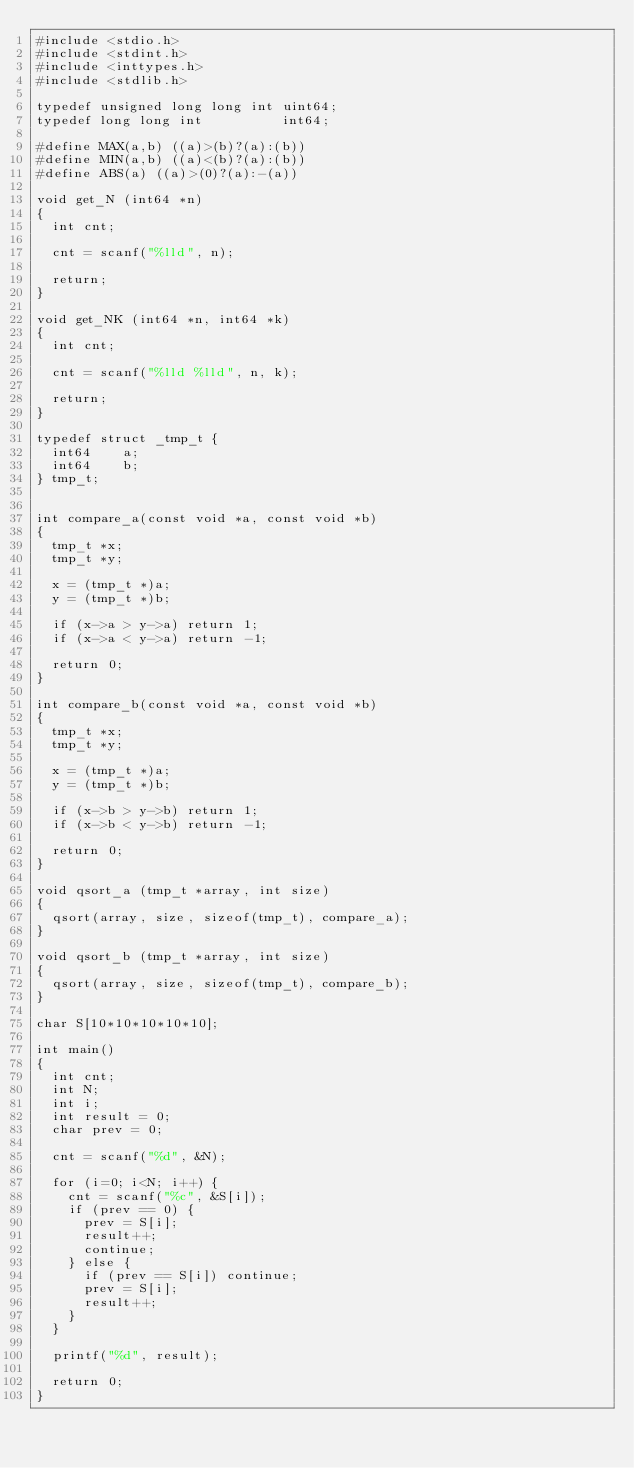<code> <loc_0><loc_0><loc_500><loc_500><_C_>#include <stdio.h>
#include <stdint.h>
#include <inttypes.h>
#include <stdlib.h>

typedef unsigned long long int uint64;
typedef long long int          int64;
 
#define MAX(a,b) ((a)>(b)?(a):(b))
#define MIN(a,b) ((a)<(b)?(a):(b))
#define ABS(a) ((a)>(0)?(a):-(a))

void get_N (int64 *n)
{
  int cnt;
  
  cnt = scanf("%lld", n);

  return;
}

void get_NK (int64 *n, int64 *k)
{
  int cnt;
  
  cnt = scanf("%lld %lld", n, k);

  return;
}

typedef struct _tmp_t {
  int64    a;
  int64    b;
} tmp_t;


int compare_a(const void *a, const void *b)
{
  tmp_t *x;
  tmp_t *y;

  x = (tmp_t *)a;
  y = (tmp_t *)b;

  if (x->a > y->a) return 1;
  if (x->a < y->a) return -1;

  return 0;
}

int compare_b(const void *a, const void *b)
{
  tmp_t *x;
  tmp_t *y;

  x = (tmp_t *)a;
  y = (tmp_t *)b;

  if (x->b > y->b) return 1;
  if (x->b < y->b) return -1;

  return 0;
}

void qsort_a (tmp_t *array, int size)
{
  qsort(array, size, sizeof(tmp_t), compare_a);
}

void qsort_b (tmp_t *array, int size)
{
  qsort(array, size, sizeof(tmp_t), compare_b);
}

char S[10*10*10*10*10];

int main()
{
  int cnt;
  int N;
  int i;
  int result = 0;
  char prev = 0;

  cnt = scanf("%d", &N);

  for (i=0; i<N; i++) {
    cnt = scanf("%c", &S[i]);
    if (prev == 0) {
      prev = S[i];
      result++;
      continue;
    } else {
      if (prev == S[i]) continue;
      prev = S[i];
      result++;
    }
  }

  printf("%d", result);

  return 0;
}

</code> 